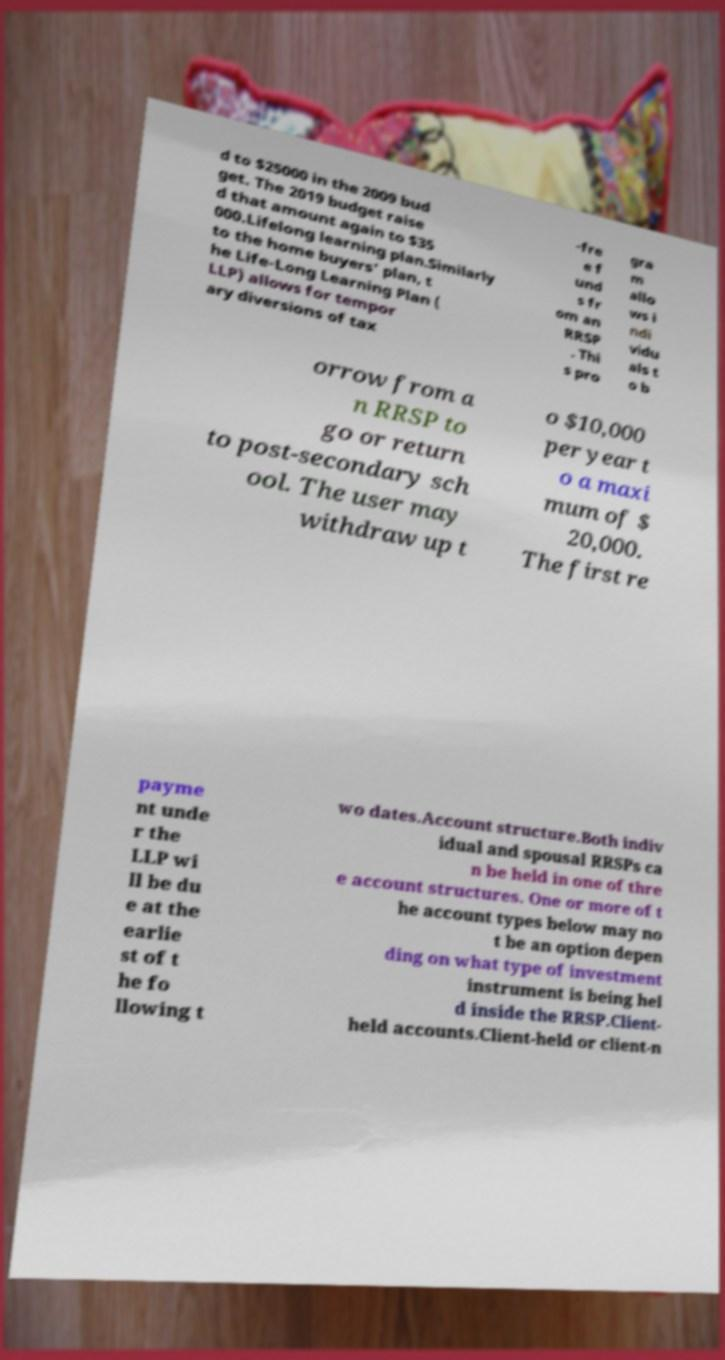Can you read and provide the text displayed in the image?This photo seems to have some interesting text. Can you extract and type it out for me? d to $25000 in the 2009 bud get. The 2019 budget raise d that amount again to $35 000.Lifelong learning plan.Similarly to the home buyers' plan, t he Life-Long Learning Plan ( LLP) allows for tempor ary diversions of tax -fre e f und s fr om an RRSP . Thi s pro gra m allo ws i ndi vidu als t o b orrow from a n RRSP to go or return to post-secondary sch ool. The user may withdraw up t o $10,000 per year t o a maxi mum of $ 20,000. The first re payme nt unde r the LLP wi ll be du e at the earlie st of t he fo llowing t wo dates.Account structure.Both indiv idual and spousal RRSPs ca n be held in one of thre e account structures. One or more of t he account types below may no t be an option depen ding on what type of investment instrument is being hel d inside the RRSP.Client- held accounts.Client-held or client-n 